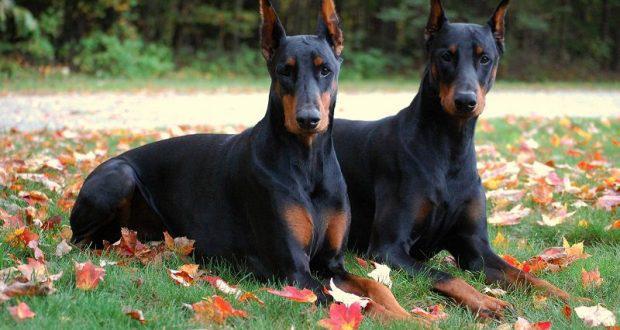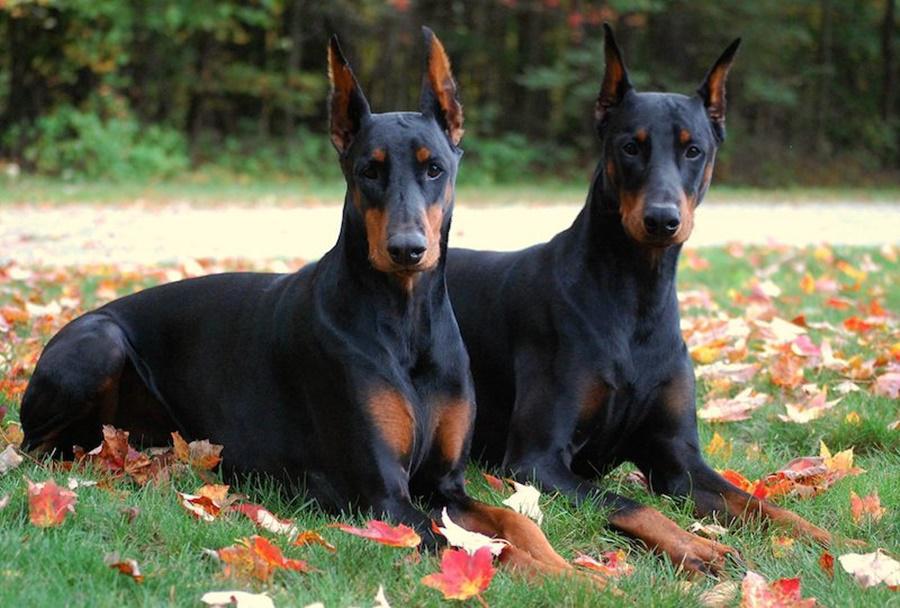The first image is the image on the left, the second image is the image on the right. Examine the images to the left and right. Is the description "The right image contains at least two dogs." accurate? Answer yes or no. Yes. 